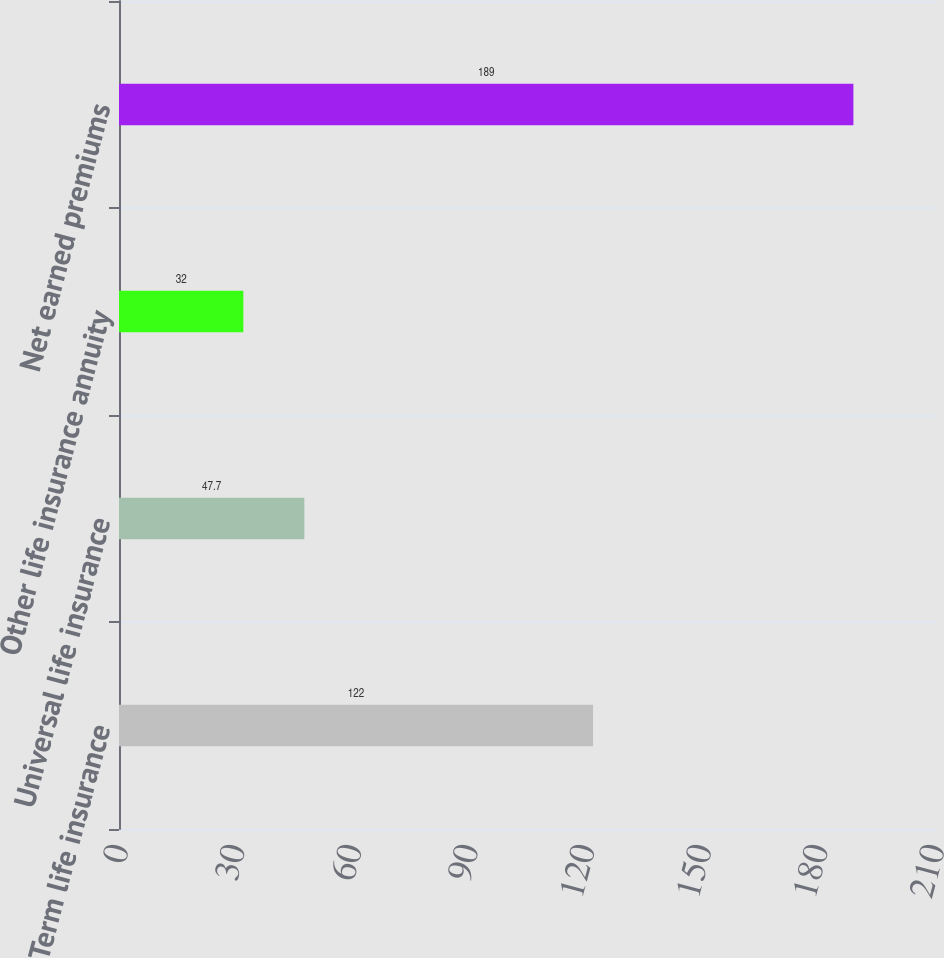<chart> <loc_0><loc_0><loc_500><loc_500><bar_chart><fcel>Term life insurance<fcel>Universal life insurance<fcel>Other life insurance annuity<fcel>Net earned premiums<nl><fcel>122<fcel>47.7<fcel>32<fcel>189<nl></chart> 